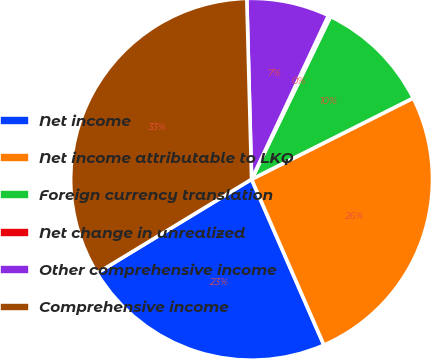<chart> <loc_0><loc_0><loc_500><loc_500><pie_chart><fcel>Net income<fcel>Net income attributable to LKQ<fcel>Foreign currency translation<fcel>Net change in unrealized<fcel>Other comprehensive income<fcel>Comprehensive income<nl><fcel>22.86%<fcel>25.86%<fcel>10.4%<fcel>0.21%<fcel>7.4%<fcel>33.26%<nl></chart> 